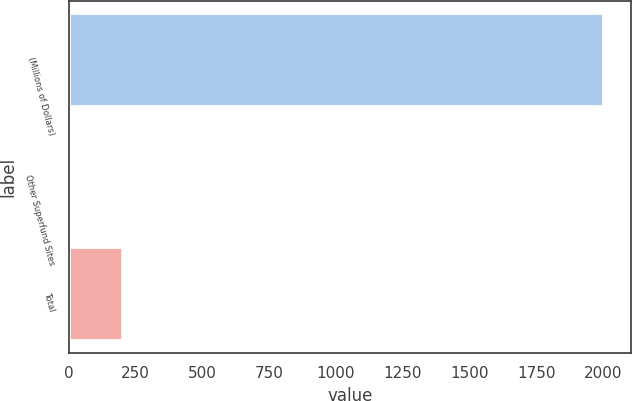Convert chart to OTSL. <chart><loc_0><loc_0><loc_500><loc_500><bar_chart><fcel>(Millions of Dollars)<fcel>Other Superfund Sites<fcel>Total<nl><fcel>2003<fcel>1<fcel>201.2<nl></chart> 